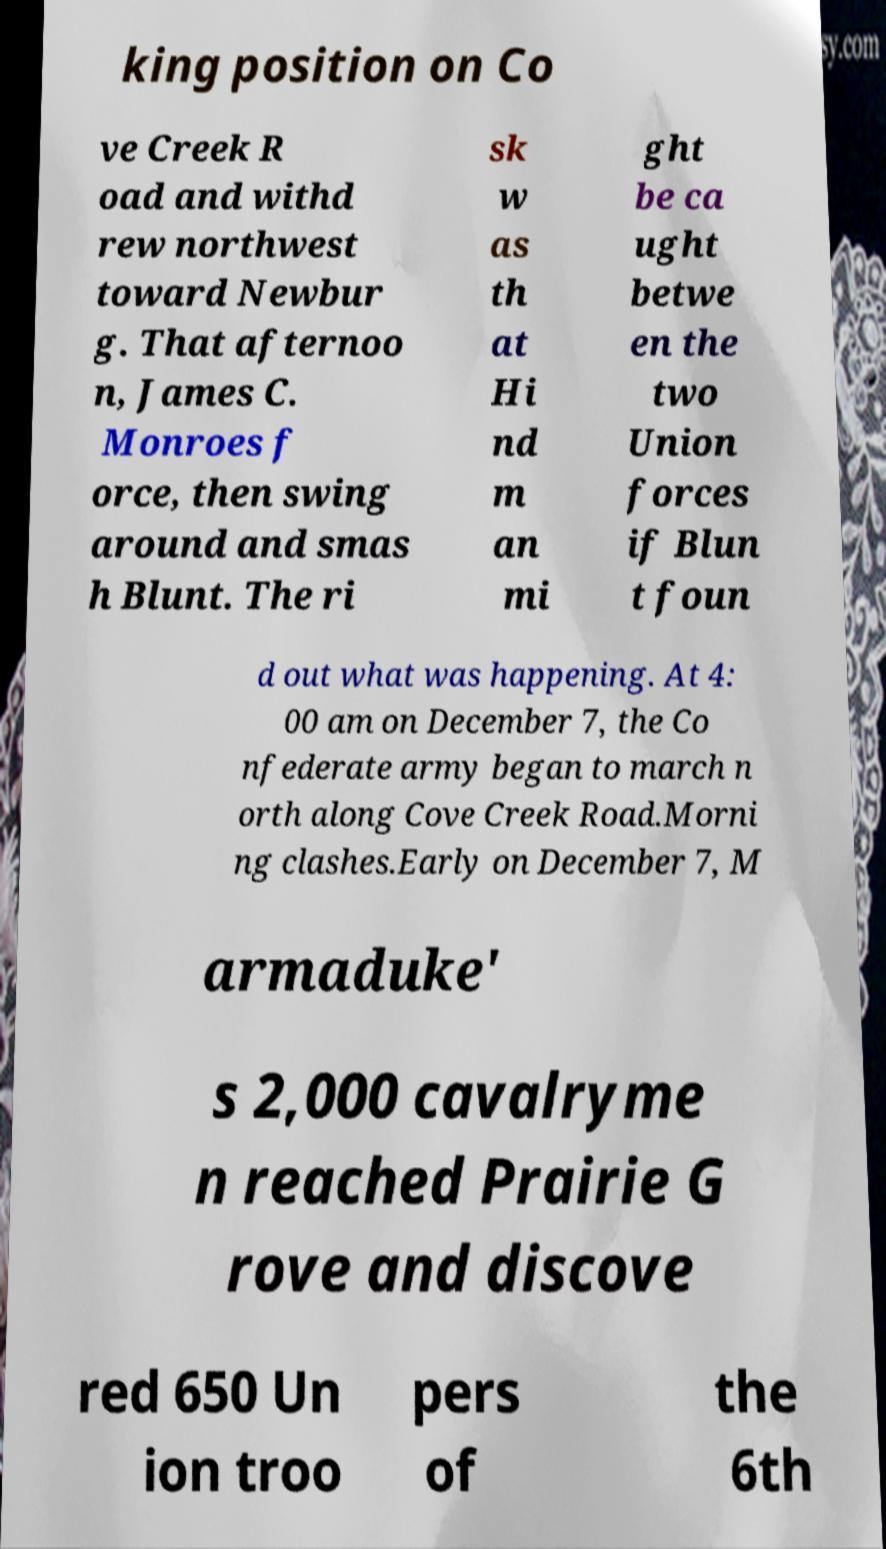What messages or text are displayed in this image? I need them in a readable, typed format. king position on Co ve Creek R oad and withd rew northwest toward Newbur g. That afternoo n, James C. Monroes f orce, then swing around and smas h Blunt. The ri sk w as th at Hi nd m an mi ght be ca ught betwe en the two Union forces if Blun t foun d out what was happening. At 4: 00 am on December 7, the Co nfederate army began to march n orth along Cove Creek Road.Morni ng clashes.Early on December 7, M armaduke' s 2,000 cavalryme n reached Prairie G rove and discove red 650 Un ion troo pers of the 6th 